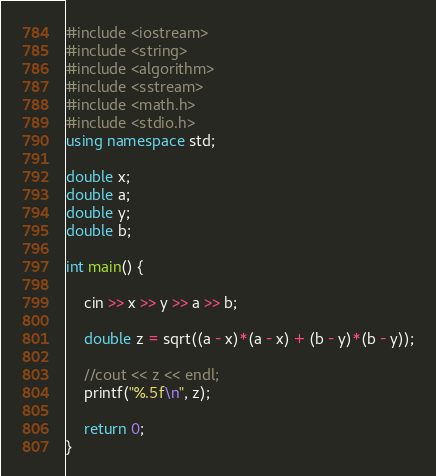<code> <loc_0><loc_0><loc_500><loc_500><_C++_>#include <iostream>
#include <string>
#include <algorithm>
#include <sstream>
#include <math.h>
#include <stdio.h>
using namespace std;

double x;
double a;
double y;
double b;

int main() {

	cin >> x >> y >> a >> b;

	double z = sqrt((a - x)*(a - x) + (b - y)*(b - y));

	//cout << z << endl;
	printf("%.5f\n", z);

	return 0;
}
</code> 